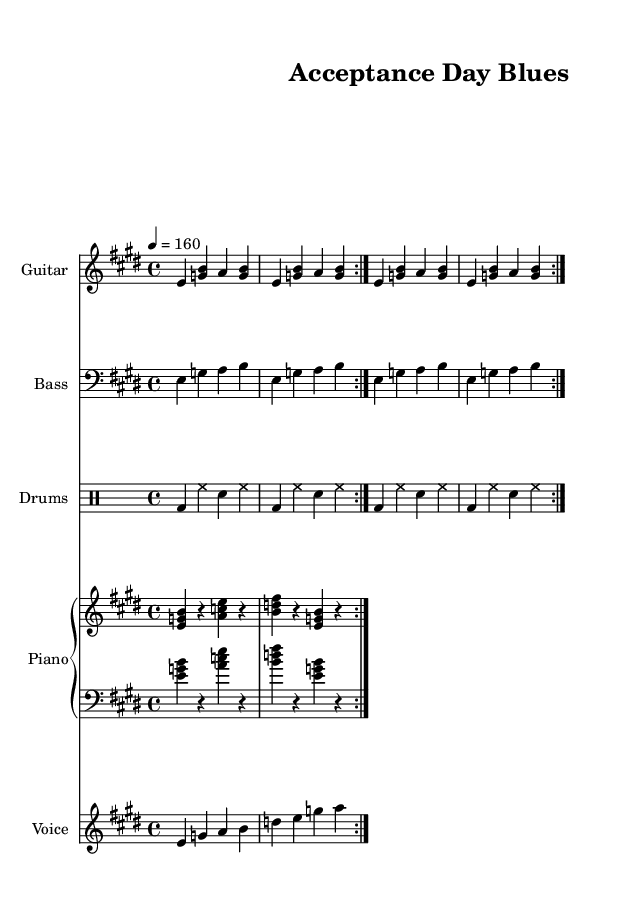What is the key signature of this music? The key signature is E major, which has four sharps (F#, C#, G#, D#). You can tell by looking at the key signature indicated at the beginning of the staff, just after the clef sign.
Answer: E major What is the time signature of this music? The time signature is 4/4, indicated at the beginning of the score before the first measure. It shows that there are four beats in each measure, and the quarter note gets one beat.
Answer: 4/4 What is the tempo marking for this piece? The tempo marking is 4 = 160, which means the piece should be played at a tempo of 160 beats per minute. This is indicated at the beginning of the score and provides a guideline for the speed of the music.
Answer: 160 How many measures are in the repeated guitar section? The repeated guitar section features two measures, repeated several times according to the repeat signs in the music. If you count the measures in the guitar part, you will find that each time it repeats, it consists of the same two measures.
Answer: 2 What genre does this song belong to? This song belongs to the Electric Blues genre, which is characterized by its strong rhythmic elements and electric instrumentation. The title "Acceptance Day Blues" and its upbeat tempo suggest its celebratory nature typical of an electric blues piece.
Answer: Electric Blues How many instruments are featured in the score? The score features five distinct instruments: Guitar, Bass, Drums, Piano, and Voice. You can tell by looking at the different staves that are labeled for each instrument in the score.
Answer: 5 What is the main theme of the lyrics in this song? The main theme of the lyrics celebrates college acceptance and academic achievement. Phrases such as "college dreams are coming true" and "Acceptance Day Blues" highlight the excitement of graduation and the journey of education.
Answer: Celebration of college acceptance 